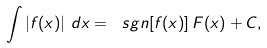Convert formula to latex. <formula><loc_0><loc_0><loc_500><loc_500>\int \left | f ( x ) \right | \, d x = \ s g n [ f ( x ) ] \, F ( x ) + C ,</formula> 